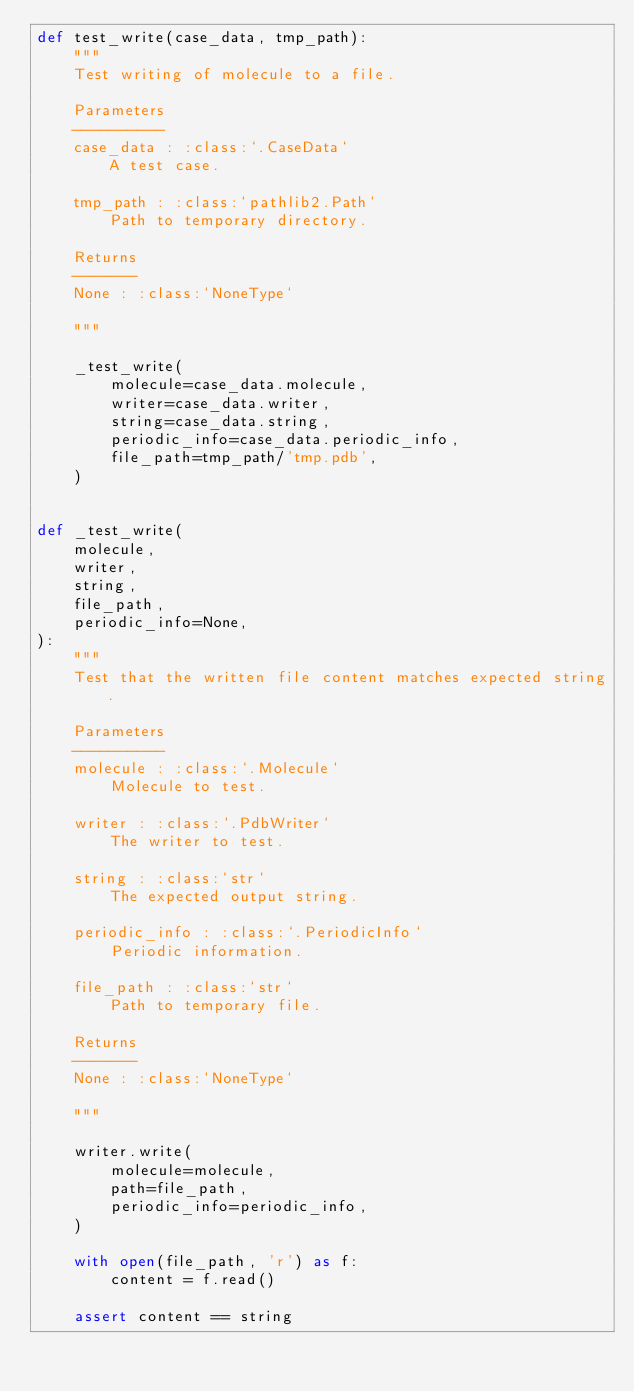<code> <loc_0><loc_0><loc_500><loc_500><_Python_>def test_write(case_data, tmp_path):
    """
    Test writing of molecule to a file.

    Parameters
    ----------
    case_data : :class:`.CaseData`
        A test case.

    tmp_path : :class:`pathlib2.Path`
        Path to temporary directory.

    Returns
    -------
    None : :class:`NoneType`

    """

    _test_write(
        molecule=case_data.molecule,
        writer=case_data.writer,
        string=case_data.string,
        periodic_info=case_data.periodic_info,
        file_path=tmp_path/'tmp.pdb',
    )


def _test_write(
    molecule,
    writer,
    string,
    file_path,
    periodic_info=None,
):
    """
    Test that the written file content matches expected string.

    Parameters
    ----------
    molecule : :class:`.Molecule`
        Molecule to test.

    writer : :class:`.PdbWriter`
        The writer to test.

    string : :class:`str`
        The expected output string.

    periodic_info : :class:`.PeriodicInfo`
        Periodic information.

    file_path : :class:`str`
        Path to temporary file.

    Returns
    -------
    None : :class:`NoneType`

    """

    writer.write(
        molecule=molecule,
        path=file_path,
        periodic_info=periodic_info,
    )

    with open(file_path, 'r') as f:
        content = f.read()

    assert content == string
</code> 